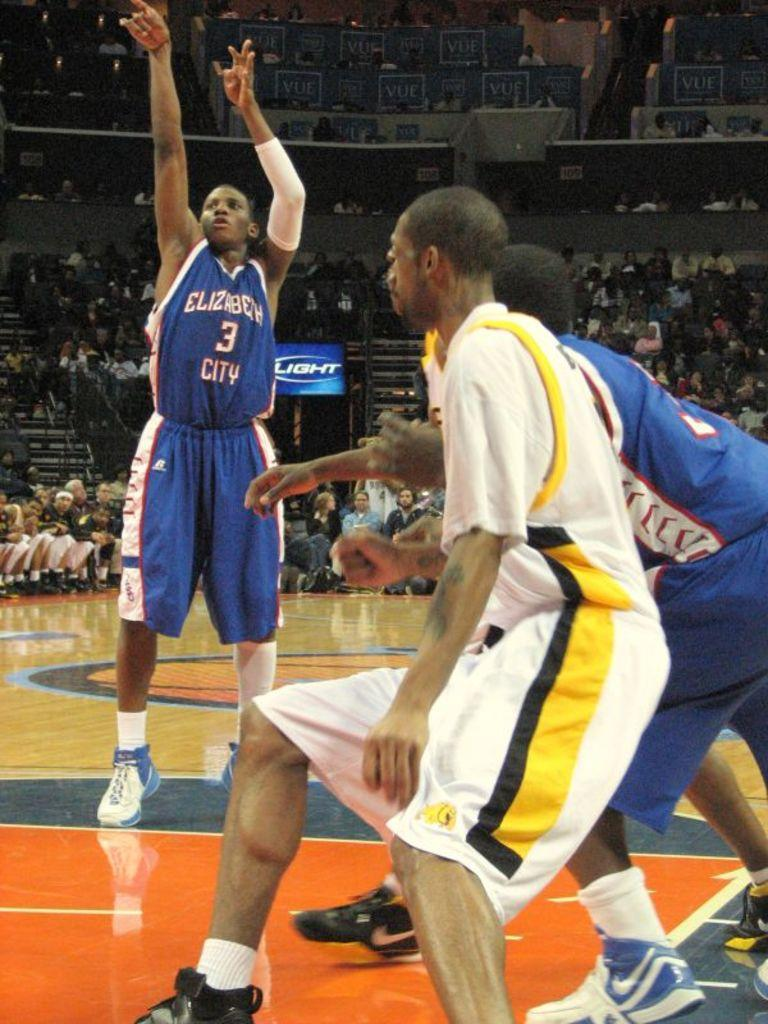What are the people in the image doing? The people in the image are playing on the path. Can you describe the action of one of the individuals? A man is jumping in the image. What can be seen behind the people playing? There are boards visible behind the people. Are there any other people in the image? Yes, some people are sitting behind the people playing. What else can be seen in the background of the image? There are other unspecified things visible in the background. What type of ear is visible on the person playing in the image? There is no ear visible on the person playing in the image. What hour is it in the image? The image does not provide any information about the time of day or hour. 